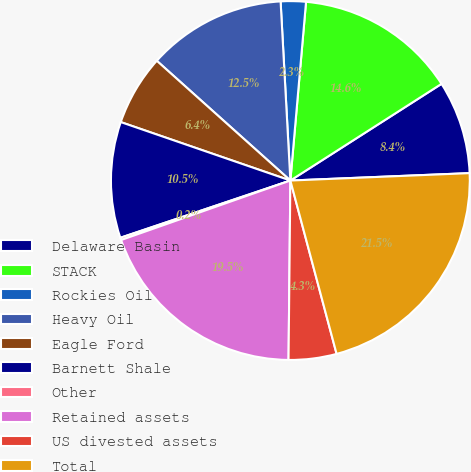Convert chart to OTSL. <chart><loc_0><loc_0><loc_500><loc_500><pie_chart><fcel>Delaware Basin<fcel>STACK<fcel>Rockies Oil<fcel>Heavy Oil<fcel>Eagle Ford<fcel>Barnett Shale<fcel>Other<fcel>Retained assets<fcel>US divested assets<fcel>Total<nl><fcel>8.4%<fcel>14.55%<fcel>2.26%<fcel>12.5%<fcel>6.35%<fcel>10.45%<fcel>0.21%<fcel>19.46%<fcel>4.31%<fcel>21.51%<nl></chart> 